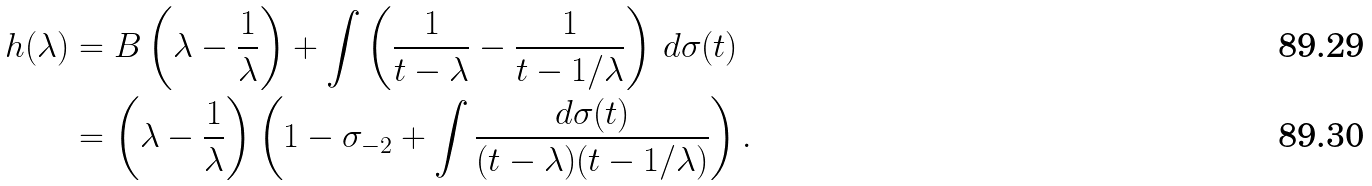Convert formula to latex. <formula><loc_0><loc_0><loc_500><loc_500>h ( \lambda ) & = B \left ( \lambda - \frac { 1 } { \lambda } \right ) + \int \left ( \frac { 1 } { t - \lambda } - \frac { 1 } { t - 1 / \lambda } \right ) \, d \sigma ( t ) \\ & = \left ( \lambda - \frac { 1 } { \lambda } \right ) \left ( 1 - \sigma _ { - 2 } + \int \frac { d \sigma ( t ) } { ( t - \lambda ) ( t - 1 / \lambda ) } \right ) .</formula> 